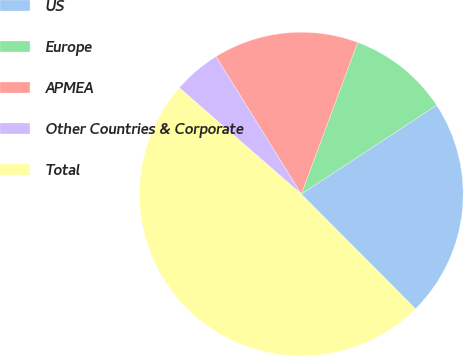Convert chart. <chart><loc_0><loc_0><loc_500><loc_500><pie_chart><fcel>US<fcel>Europe<fcel>APMEA<fcel>Other Countries & Corporate<fcel>Total<nl><fcel>21.8%<fcel>10.09%<fcel>14.5%<fcel>4.76%<fcel>48.86%<nl></chart> 